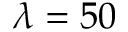<formula> <loc_0><loc_0><loc_500><loc_500>\lambda = 5 0</formula> 